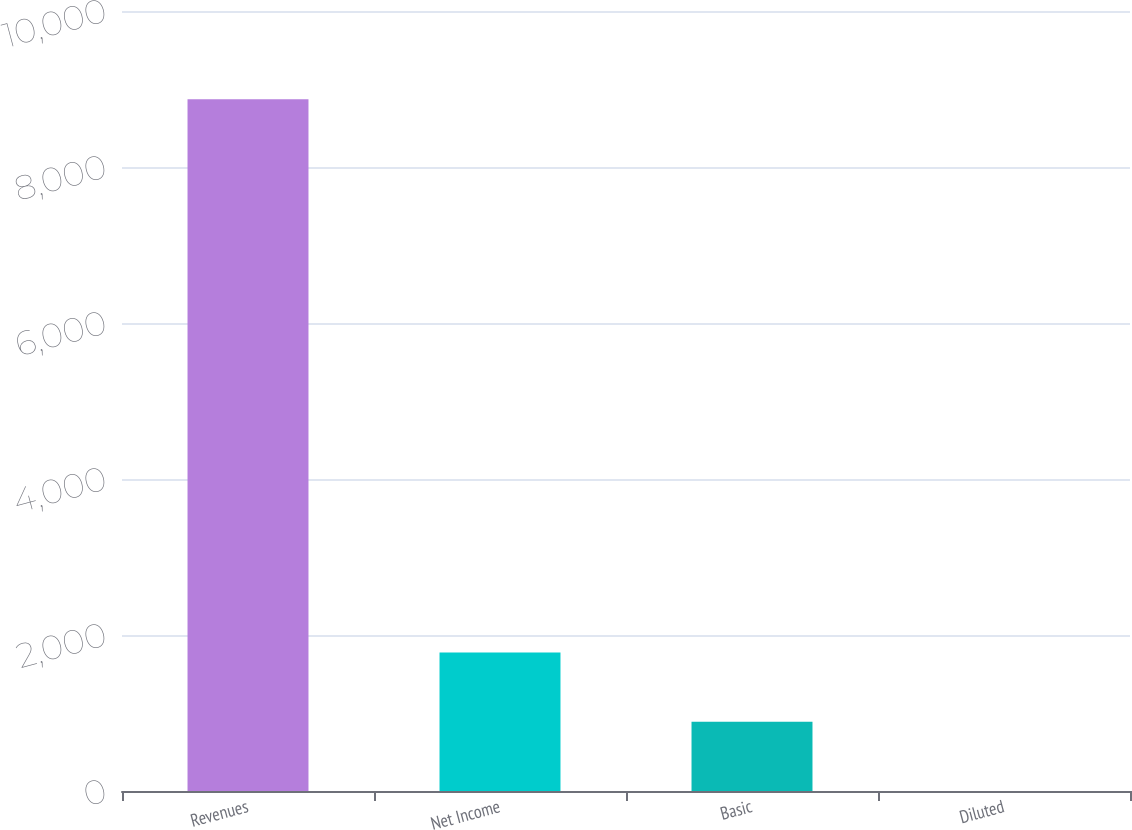Convert chart to OTSL. <chart><loc_0><loc_0><loc_500><loc_500><bar_chart><fcel>Revenues<fcel>Net Income<fcel>Basic<fcel>Diluted<nl><fcel>8870<fcel>1774.57<fcel>887.64<fcel>0.71<nl></chart> 